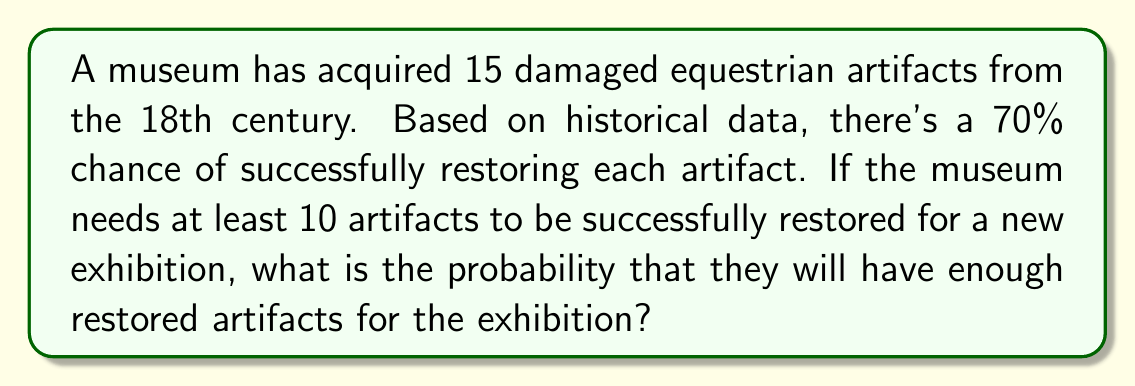Give your solution to this math problem. To solve this problem, we can use the binomial probability distribution:

1) Let X be the number of successfully restored artifacts.
   X follows a binomial distribution with n = 15 and p = 0.7

2) We need to find P(X ≥ 10)

3) This can be calculated as 1 - P(X < 10) or 1 - P(X ≤ 9)

4) Using the cumulative binomial probability formula:

   $$P(X \leq k) = \sum_{i=0}^k \binom{n}{i} p^i (1-p)^{n-i}$$

5) In our case:
   $$P(X \geq 10) = 1 - P(X \leq 9) = 1 - \sum_{i=0}^9 \binom{15}{i} (0.7)^i (0.3)^{15-i}$$

6) Calculating this (using a calculator or computer due to the complexity):

   $$1 - (0.0000 + 0.0000 + 0.0001 + 0.0008 + 0.0037 + 0.0132 + 0.0369 + 0.0788 + 0.1268 + 0.1529) = 0.7868$$

7) Convert to percentage: 0.7868 * 100 = 78.68%

Therefore, there is approximately a 78.68% chance that the museum will have enough restored artifacts for the exhibition.
Answer: 78.68% 